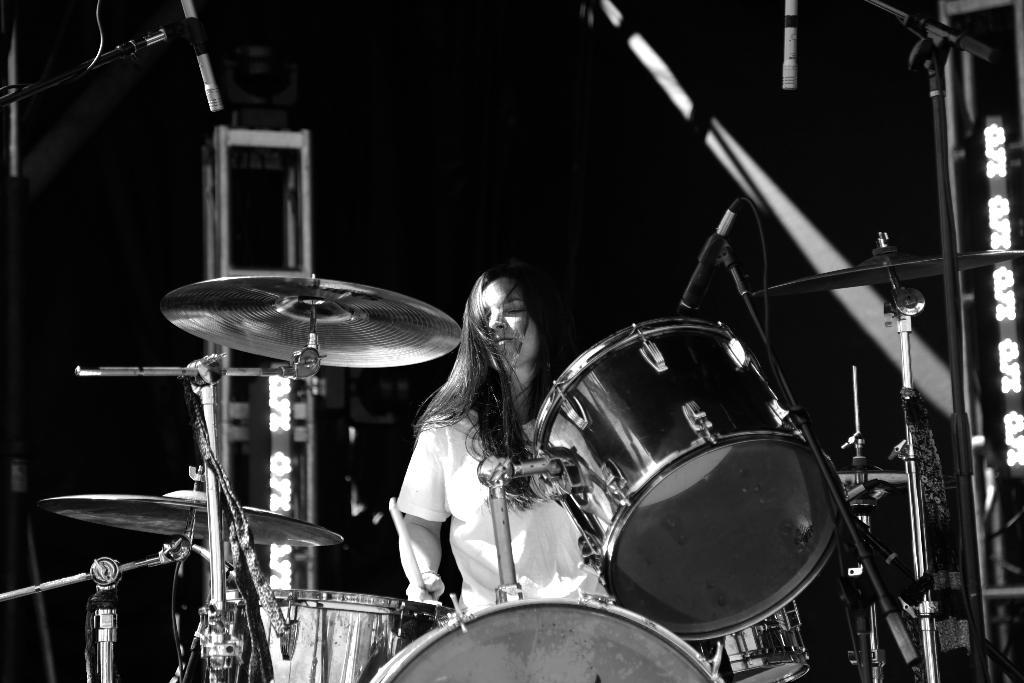What is the lady in the image doing? The lady is playing a band in the image. What can be seen on the left side of the image? There is a stand on the left side of the image. What is in the center of the image? There is a microphone (mic) in the center of the image. Can you see a kitten playing with a unit on the island in the image? No, there is no kitten, unit, or island present in the image. 